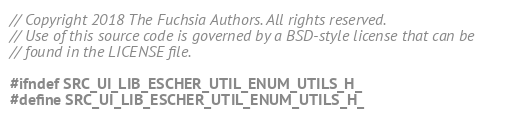Convert code to text. <code><loc_0><loc_0><loc_500><loc_500><_C_>// Copyright 2018 The Fuchsia Authors. All rights reserved.
// Use of this source code is governed by a BSD-style license that can be
// found in the LICENSE file.

#ifndef SRC_UI_LIB_ESCHER_UTIL_ENUM_UTILS_H_
#define SRC_UI_LIB_ESCHER_UTIL_ENUM_UTILS_H_
</code> 